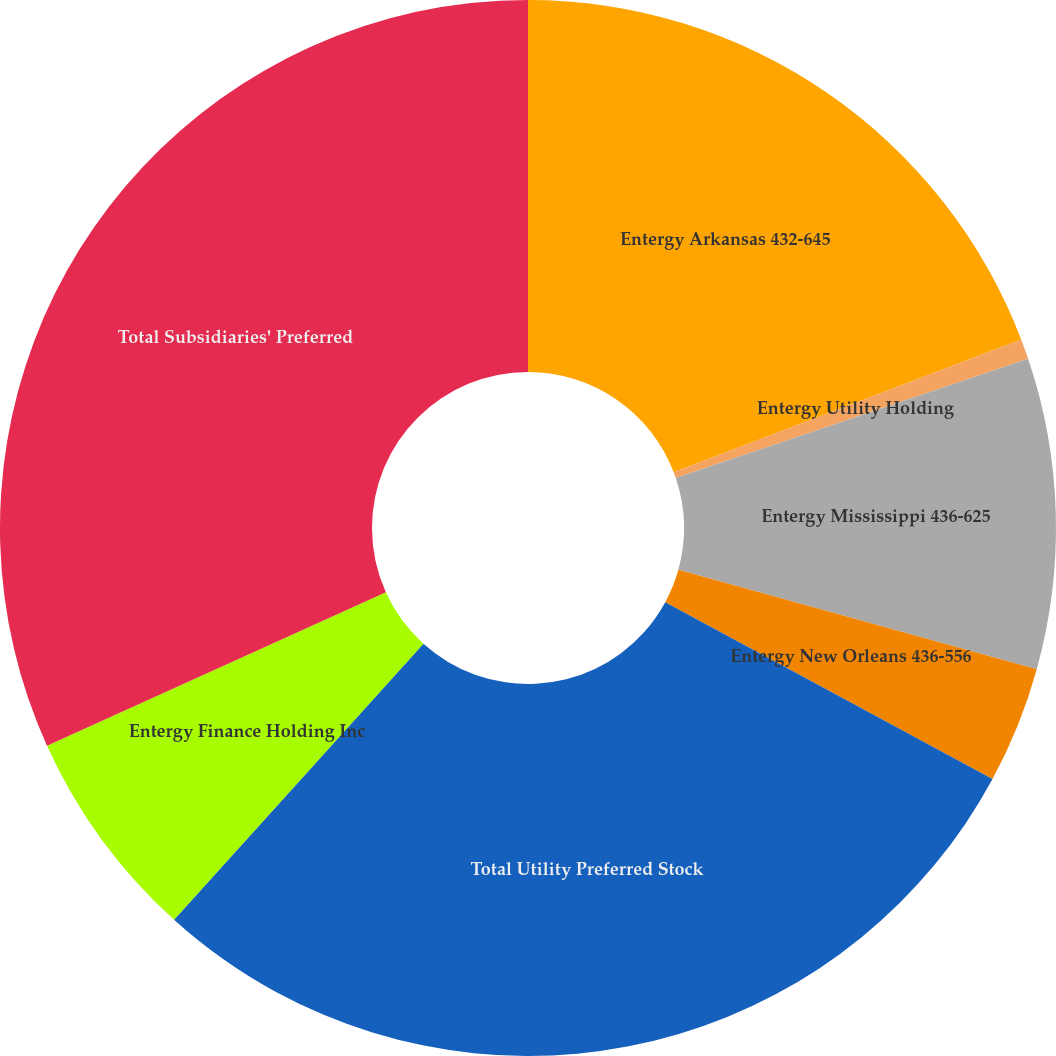Convert chart. <chart><loc_0><loc_0><loc_500><loc_500><pie_chart><fcel>Entergy Arkansas 432-645<fcel>Entergy Utility Holding<fcel>Entergy Mississippi 436-625<fcel>Entergy New Orleans 436-556<fcel>Total Utility Preferred Stock<fcel>Entergy Finance Holding Inc<fcel>Total Subsidiaries' Preferred<nl><fcel>19.19%<fcel>0.62%<fcel>9.5%<fcel>3.58%<fcel>28.81%<fcel>6.54%<fcel>31.77%<nl></chart> 